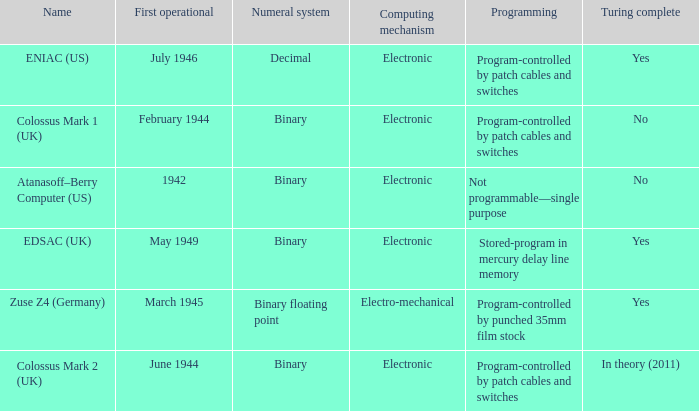What's the turing complete with numeral system being decimal Yes. 